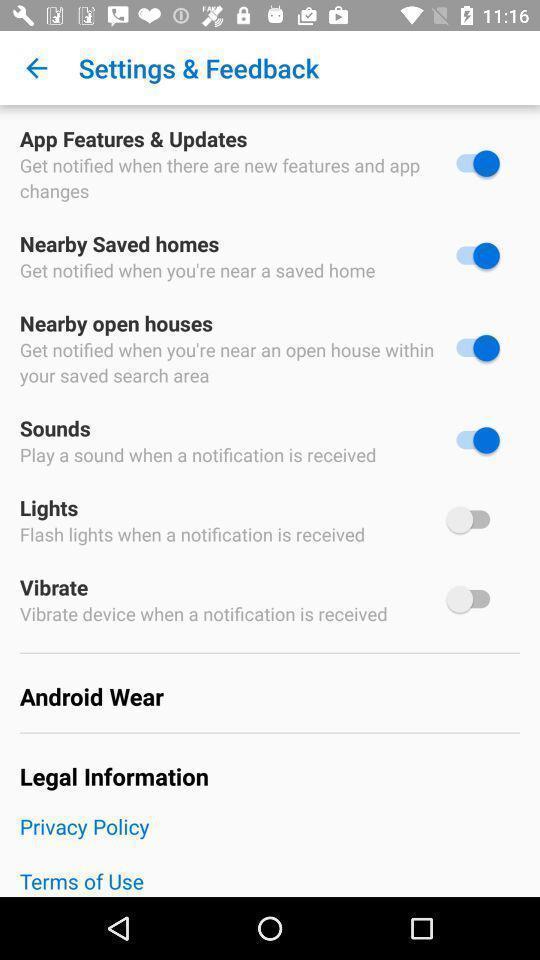Describe the visual elements of this screenshot. Settings and feedback page with options. 